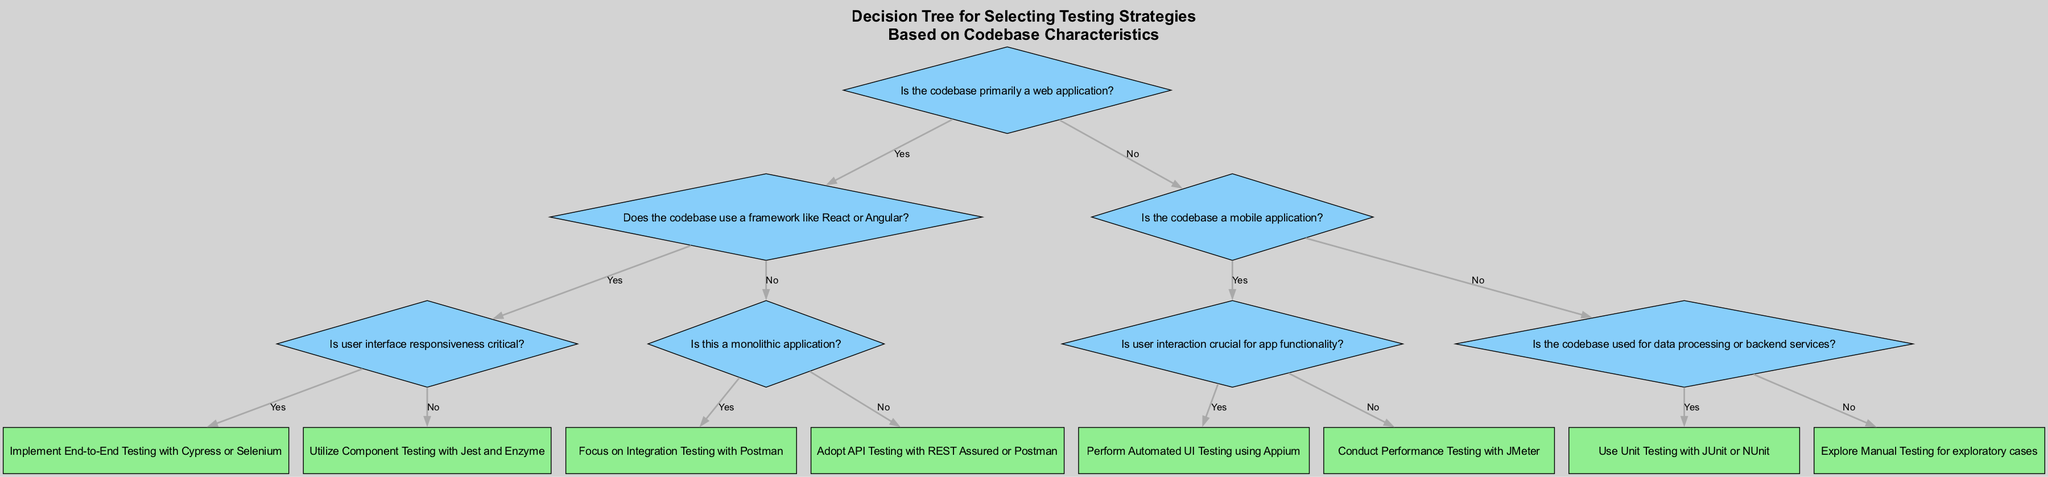What is the first question in the decision tree? The first question posed in the decision tree is "Is the codebase primarily a web application?"
Answer: Is the codebase primarily a web application? What strategy is suggested if the codebase uses a framework like React or Angular and user interface responsiveness is critical? If the codebase uses a framework like React or Angular and user interface responsiveness is critical, the strategy suggested is "Implement End-to-End Testing with Cypress or Selenium."
Answer: Implement End-to-End Testing with Cypress or Selenium How many main branches are there at the root of the decision tree? The root of the decision tree has two main branches: one for web applications and one for non-web applications. Thus, there are two branches.
Answer: Two What happens if the codebase is not a mobile application and is used for data processing or backend services? If the codebase is not a mobile application and is used for data processing or backend services, the strategy selected will be "Use Unit Testing with JUnit or NUnit."
Answer: Use Unit Testing with JUnit or NUnit What is the relationship between "Is the codebase primarily a web application?" and "Is this a monolithic application?" "Is this a monolithic application?" is a sub-question that arises if the answer to "Is the codebase primarily a web application?" is "no." It follows the decision path for non-web applications.
Answer: Sub-question in non-web path If the codebase does not use a framework like React or Angular and is not a monolithic application, what type of testing is suggested? If the codebase does not use a framework like React or Angular and is not a monolithic application, the decision tree suggests "Adopt API Testing with REST Assured or Postman."
Answer: Adopt API Testing with REST Assured or Postman Which strategy is chosen if user interaction is crucial for a mobile application? If user interaction is crucial for a mobile application, the strategy selected is "Perform Automated UI Testing using Appium."
Answer: Perform Automated UI Testing using Appium How does the decision tree recommend testing if the codebase is neither a web application nor a mobile application? If the codebase is neither a web application nor a mobile application, the decision tree leads to "Explore Manual Testing for exploratory cases."
Answer: Explore Manual Testing for exploratory cases 